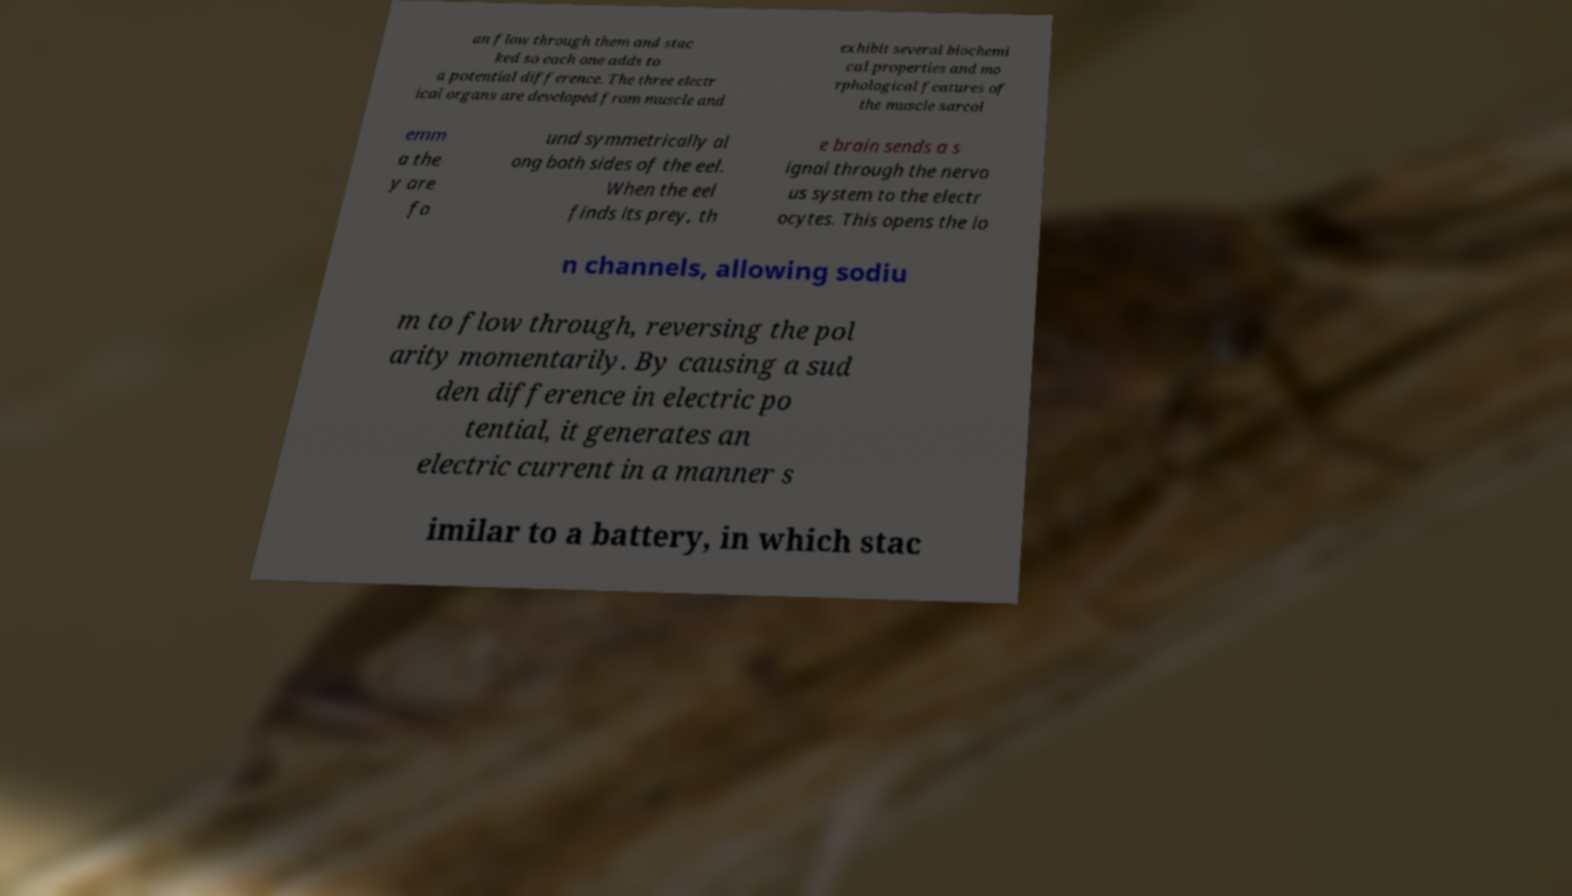Please identify and transcribe the text found in this image. an flow through them and stac ked so each one adds to a potential difference. The three electr ical organs are developed from muscle and exhibit several biochemi cal properties and mo rphological features of the muscle sarcol emm a the y are fo und symmetrically al ong both sides of the eel. When the eel finds its prey, th e brain sends a s ignal through the nervo us system to the electr ocytes. This opens the io n channels, allowing sodiu m to flow through, reversing the pol arity momentarily. By causing a sud den difference in electric po tential, it generates an electric current in a manner s imilar to a battery, in which stac 